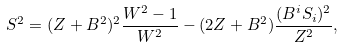Convert formula to latex. <formula><loc_0><loc_0><loc_500><loc_500>S ^ { 2 } = ( Z + B ^ { 2 } ) ^ { 2 } \frac { W ^ { 2 } - 1 } { W ^ { 2 } } - ( 2 Z + B ^ { 2 } ) \frac { ( B ^ { i } S _ { i } ) ^ { 2 } } { Z ^ { 2 } } ,</formula> 